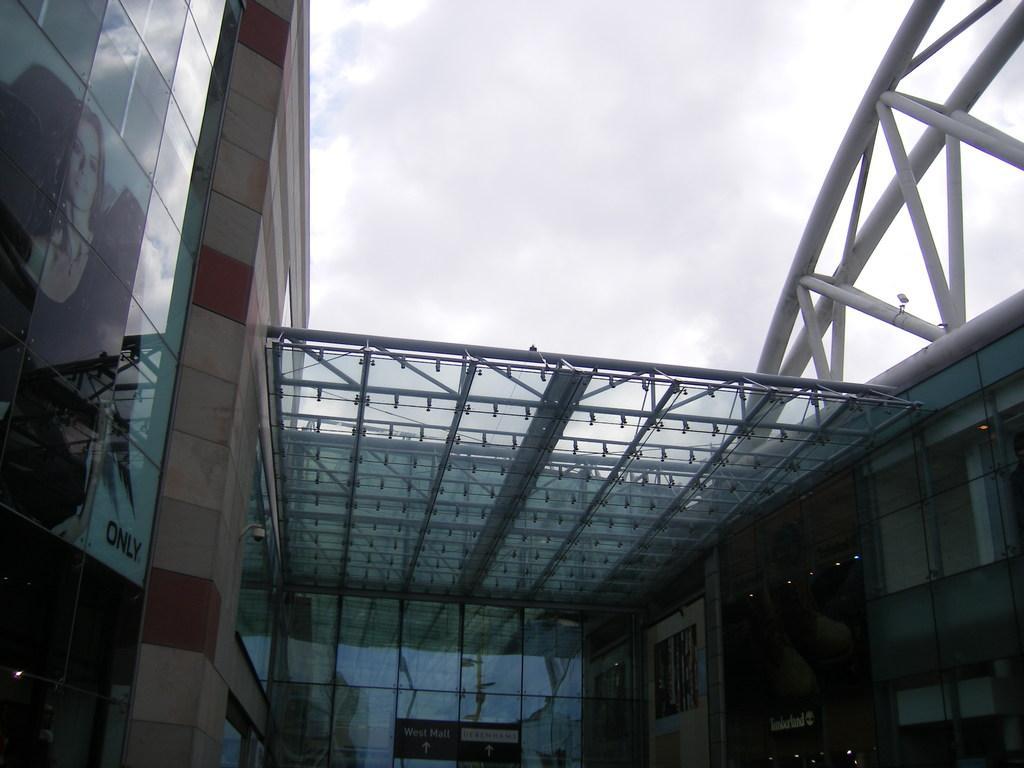Please provide a concise description of this image. In this picture there are buildings on the right and left side of the image and there is a poster on the left side of the image and there is a roof in the center of the image. 